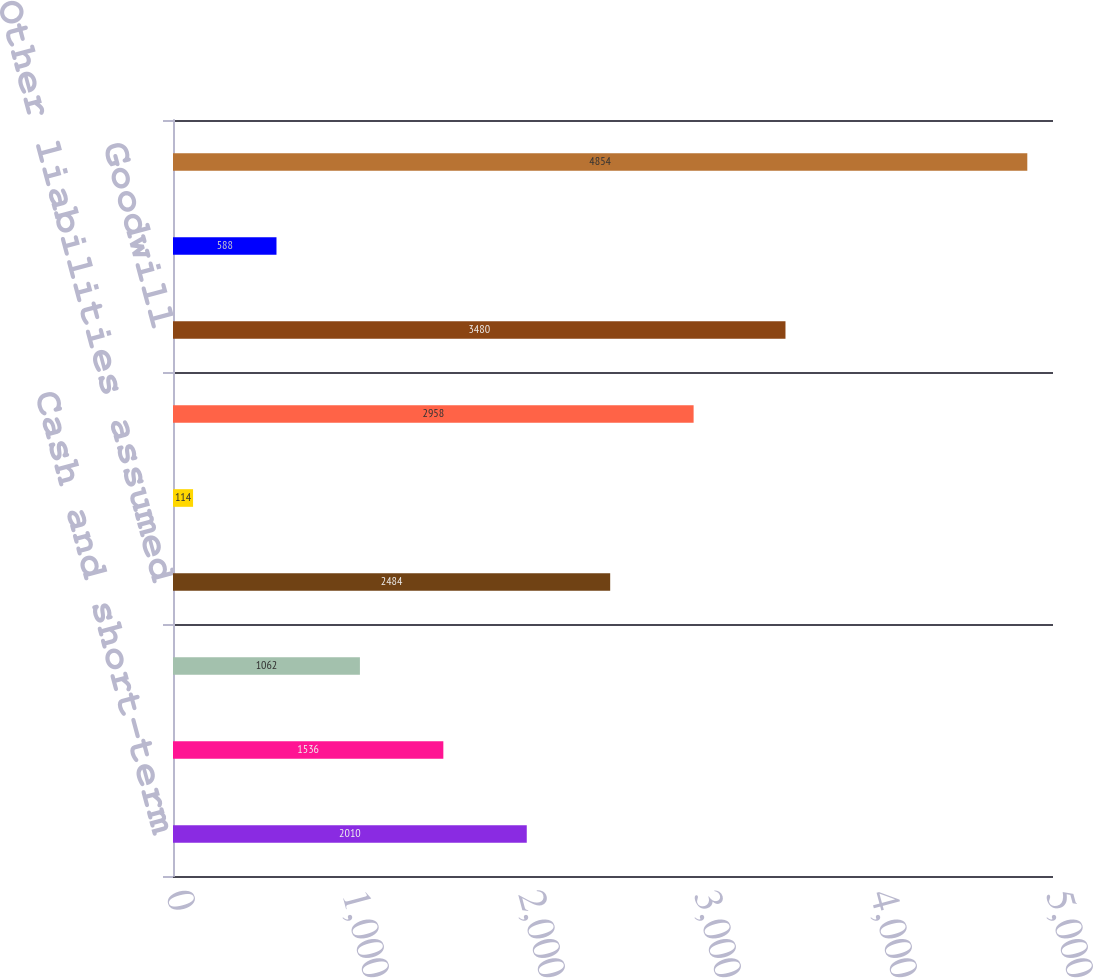Convert chart. <chart><loc_0><loc_0><loc_500><loc_500><bar_chart><fcel>Cash and short-term<fcel>Other tangible assets<fcel>Notes payable<fcel>Other liabilities assumed<fcel>Total net assets<fcel>Amortizable intangible assets<fcel>Goodwill<fcel>IPR&D<fcel>Total purchase price<nl><fcel>2010<fcel>1536<fcel>1062<fcel>2484<fcel>114<fcel>2958<fcel>3480<fcel>588<fcel>4854<nl></chart> 